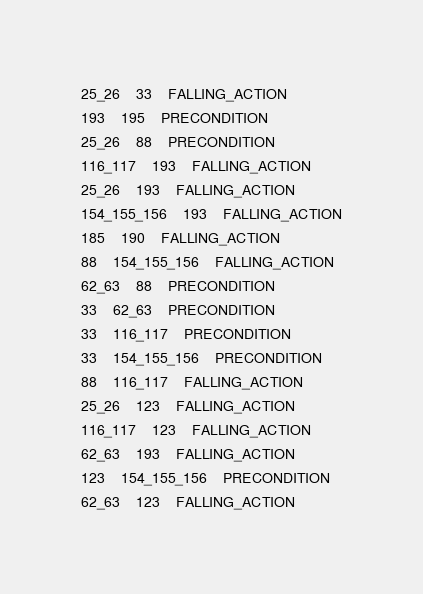Convert code to text. <code><loc_0><loc_0><loc_500><loc_500><_XML_>25_26	33	FALLING_ACTION
193	195	PRECONDITION
25_26	88	PRECONDITION
116_117	193	FALLING_ACTION
25_26	193	FALLING_ACTION
154_155_156	193	FALLING_ACTION
185	190	FALLING_ACTION
88	154_155_156	FALLING_ACTION
62_63	88	PRECONDITION
33	62_63	PRECONDITION
33	116_117	PRECONDITION
33	154_155_156	PRECONDITION
88	116_117	FALLING_ACTION
25_26	123	FALLING_ACTION
116_117	123	FALLING_ACTION
62_63	193	FALLING_ACTION
123	154_155_156	PRECONDITION
62_63	123	FALLING_ACTION
</code> 